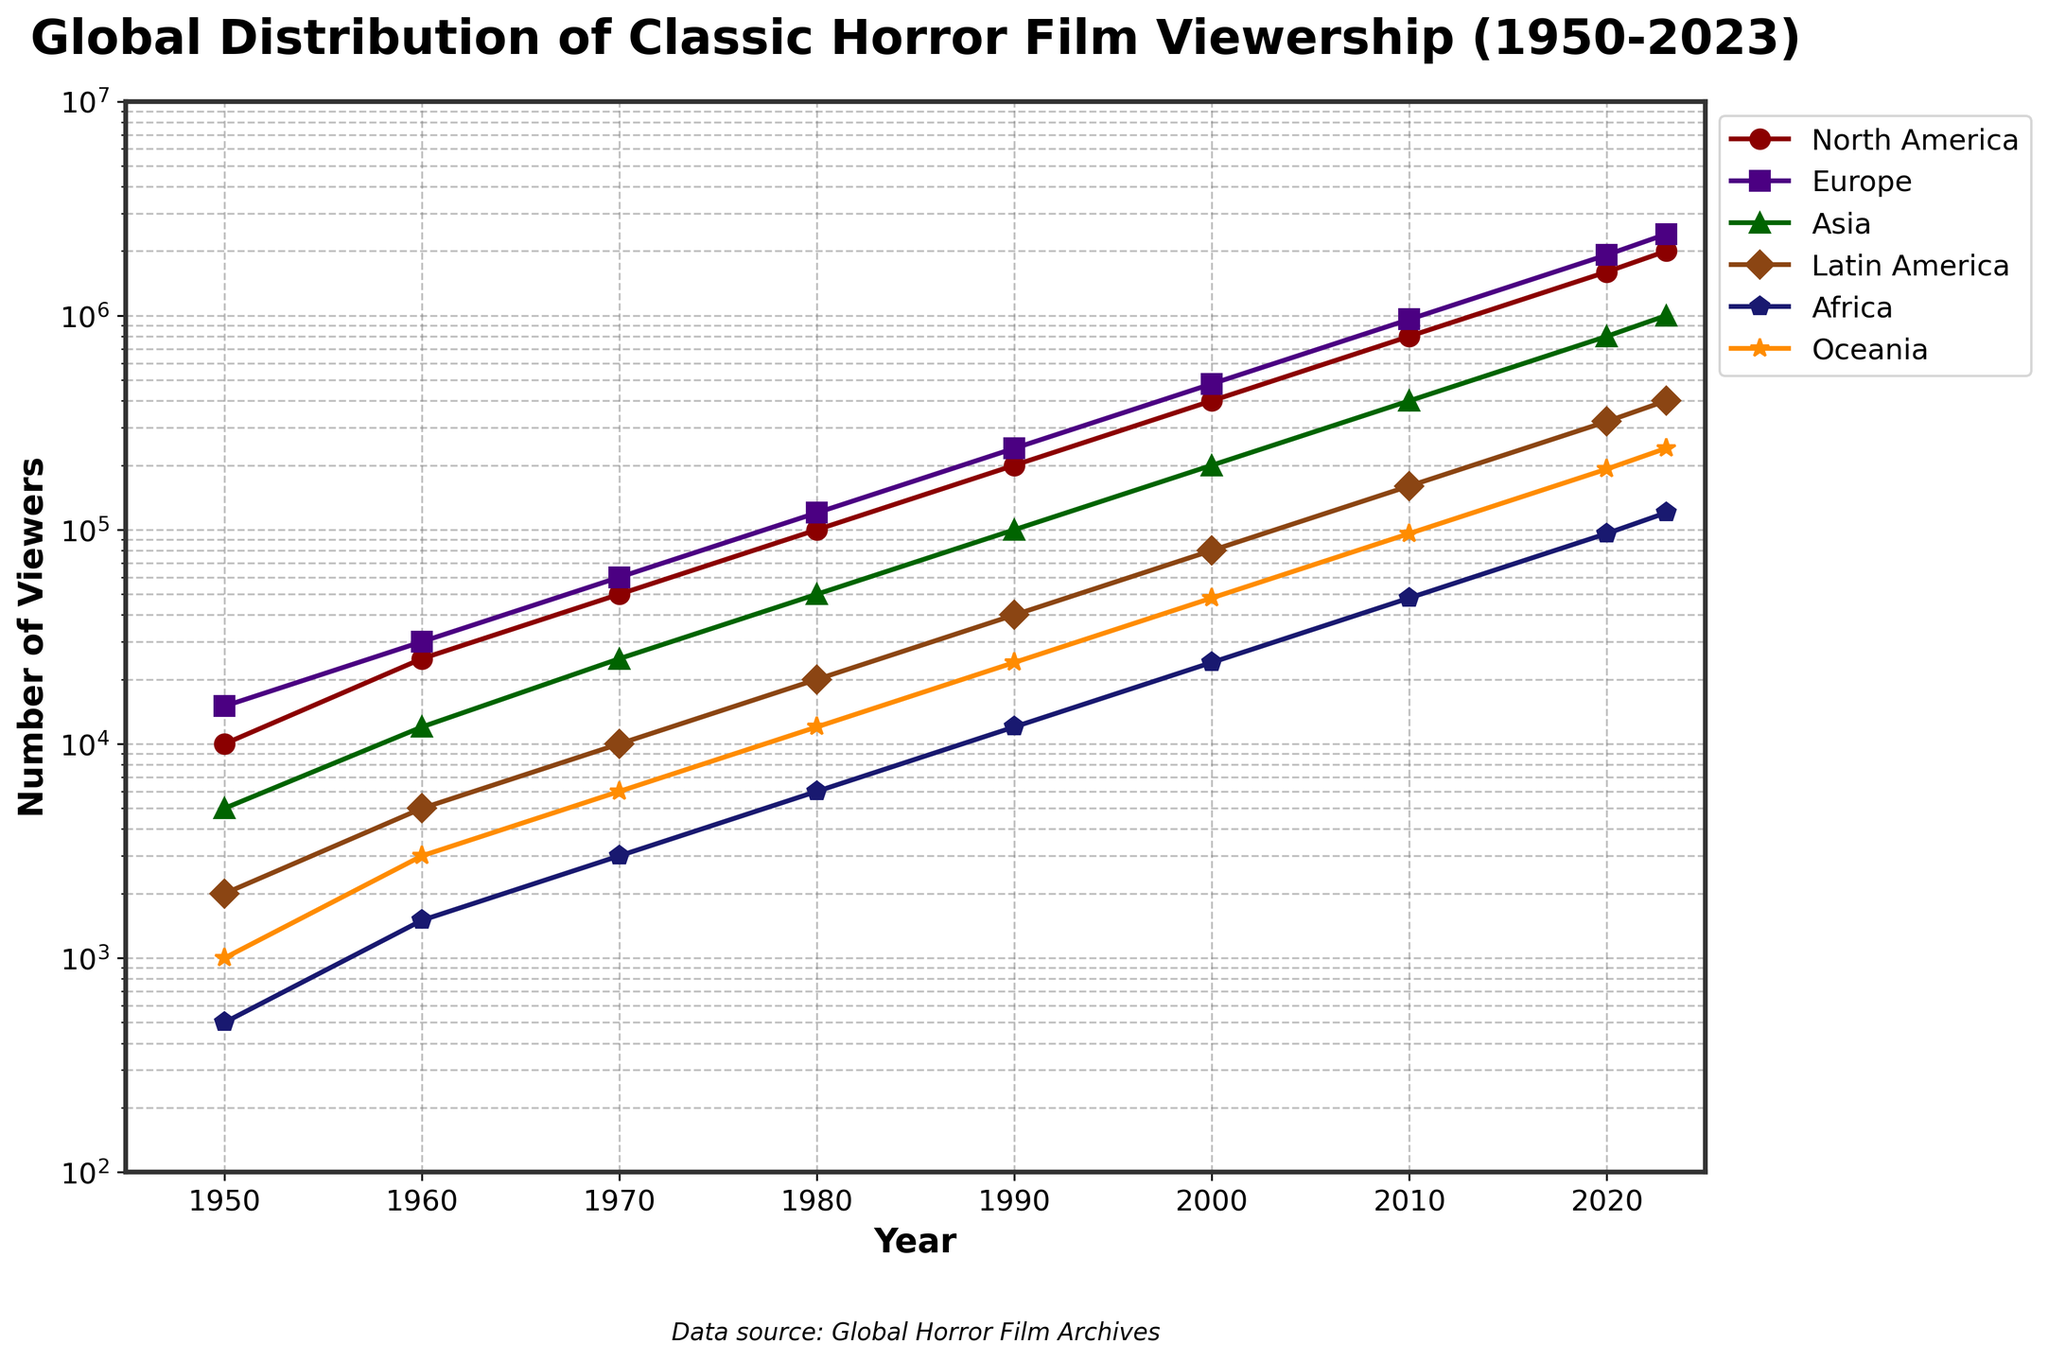What year did viewership in North America first exceed 1,000,000? According to the plot, North America's viewership reached 1,000,000 between 2010 and 2020. In 2020, it exceeded 1,000,000.
Answer: 2020 How does the viewership trend in Europe compare to that in North America between 1950 and 2023? From the plot, both regions show a sharp upward trend, with Europe having consistently higher viewership than North America over the entire period. Europe also follows North America's pattern of doubling viewership approximately every decade.
Answer: Europe consistently higher By how much did viewership in Asia increase from 1950 to 2023? In 1950, Asia had a viewership of 5,000. By 2023, the viewership had grown to 1,000,000. The increase is 1,000,000 - 5,000.
Answer: 995,000 Which regions had a viewership over 400,000 in 2023? In 2023, North America, Europe, Asia, and Oceania had viewerships over 400,000 according to the plot.
Answer: North America, Europe, Asia, Oceania What is the ratio of viewers in Latin America to total viewers in 1970? In 1970, Latin America's viewership was 10,000. The total viewership when summed across all regions is 150,000. The ratio is 10,000/150,000.
Answer: 1:15 Between 1980 and 1990, which region saw the largest numeric growth in viewership? By comparing the viewership numbers from 1980 to 1990, North America grew from 100,000 to 200,000, Europe from 120,000 to 240,000, Asia from 50,000 to 100,000. The largest numeric growth was in Europe (120,000 increase).
Answer: Europe In what year did Oceania's viewership first exceed 10,000? The plot shows that Oceania's viewership first exceeded 10,000 between 1980 and 1990. It was above 10,000 in 1990.
Answer: 1990 If combining Africa and Latin America's viewership in 2010, how does it compare to North America's viewership that year? In 2010, Africa had 48,000 viewers and Latin America had 160,000 viewers. Combining them gives 208,000, which is significantly less than North America's 800,000.
Answer: Less 